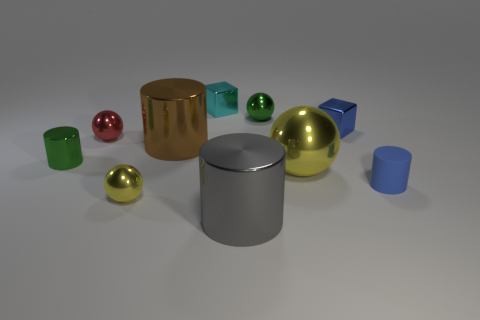Subtract 1 cylinders. How many cylinders are left? 3 Subtract all cylinders. How many objects are left? 6 Subtract all gray things. Subtract all small blue rubber things. How many objects are left? 8 Add 8 tiny green things. How many tiny green things are left? 10 Add 4 large yellow matte things. How many large yellow matte things exist? 4 Subtract 0 brown cubes. How many objects are left? 10 